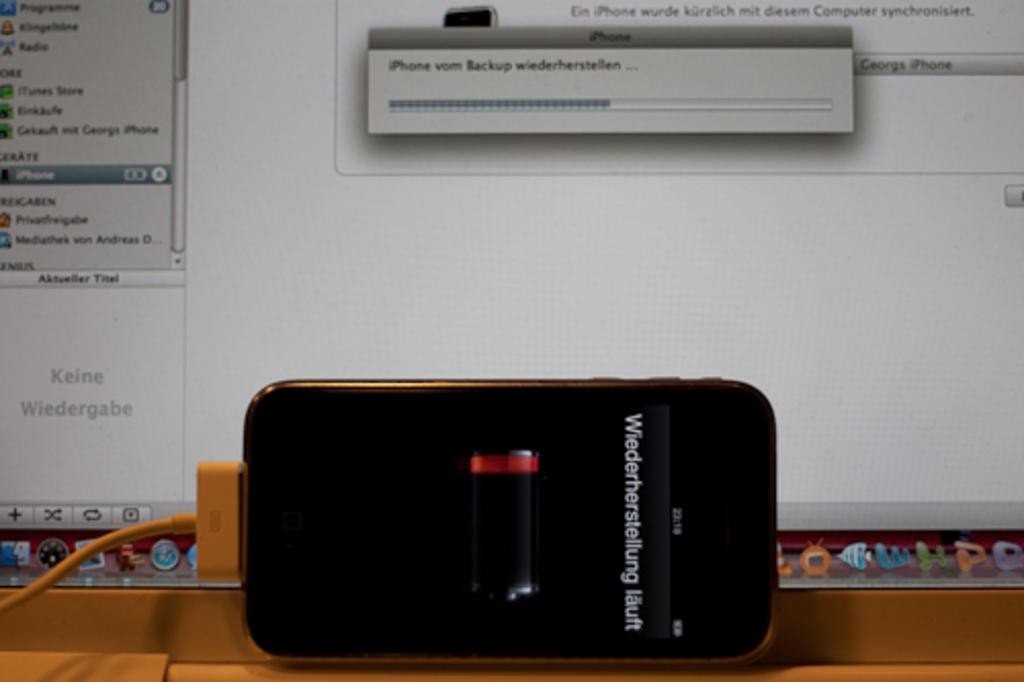Provide a one-sentence caption for the provided image. An iPhone connected to a macbook running iPhone vom Backup wiederherstellen. 